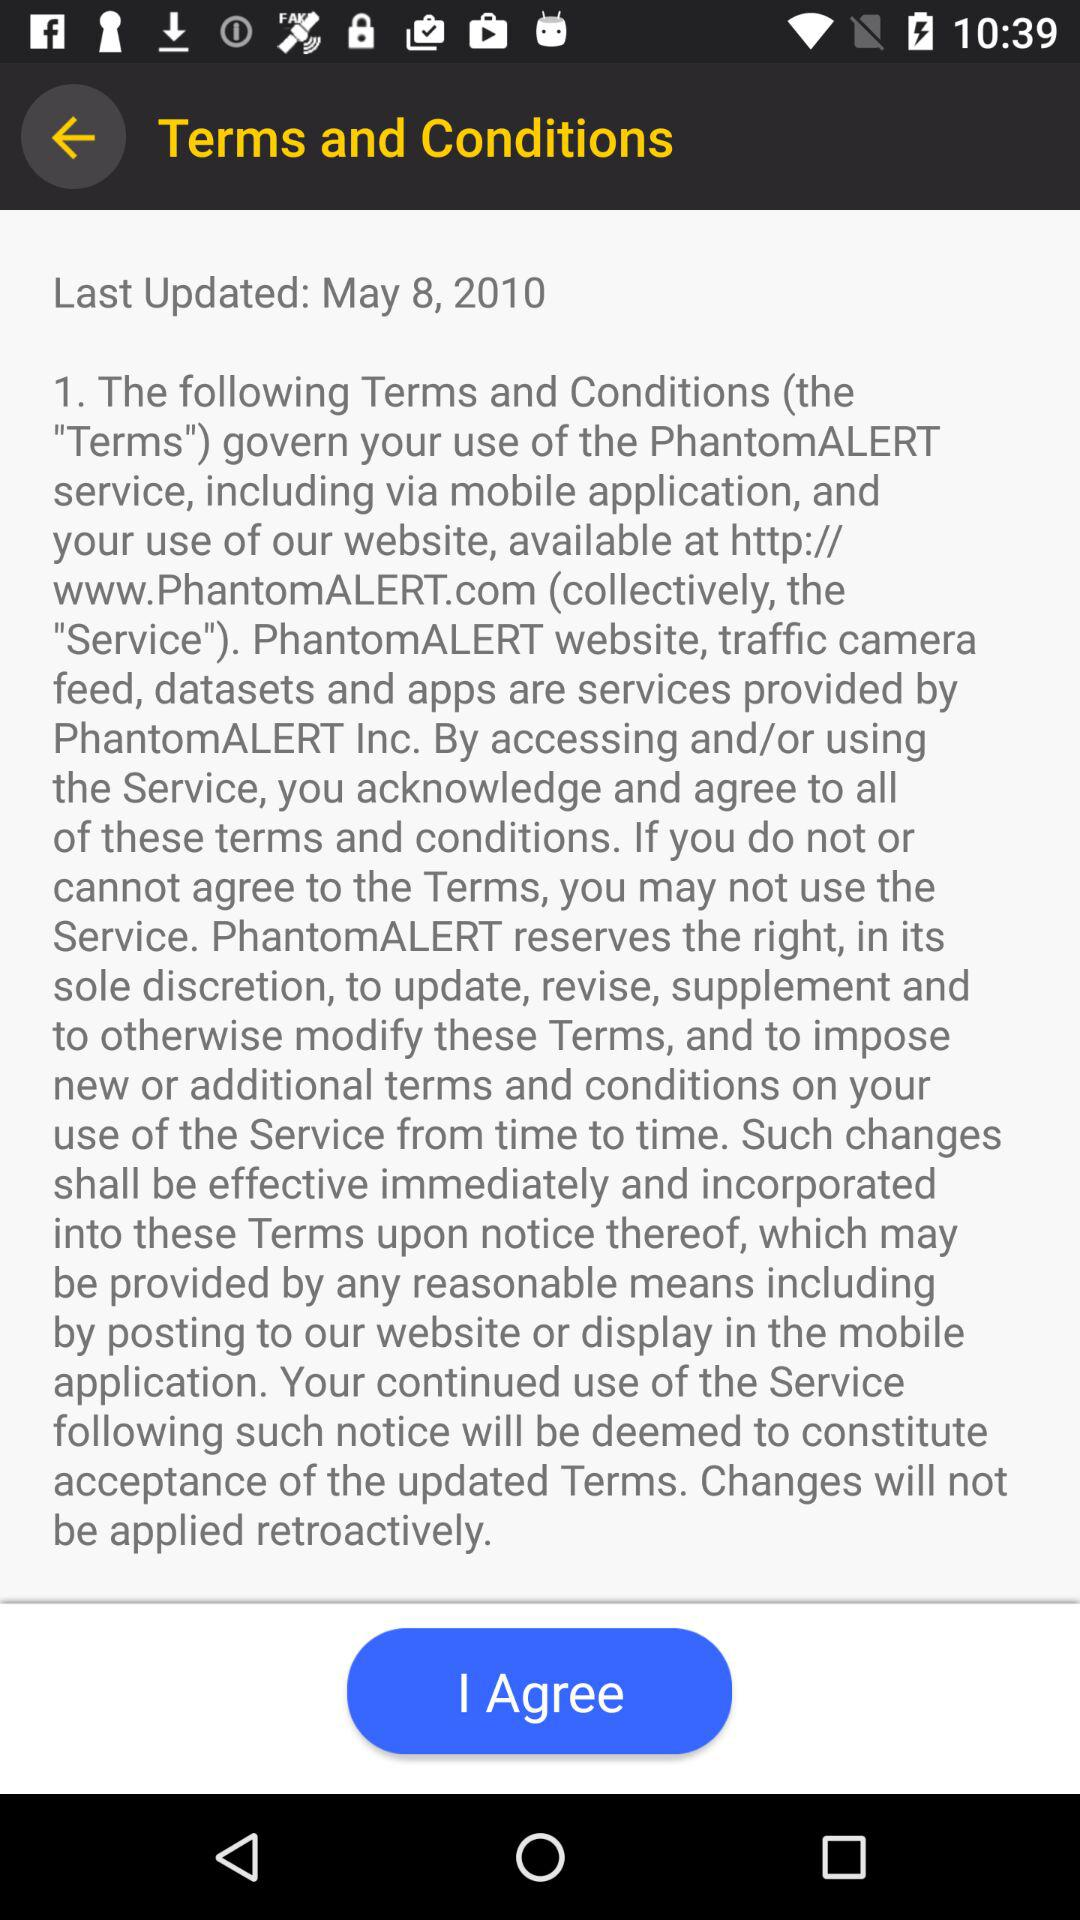On what date the last update was done? The last update was done on May 8, 2010. 